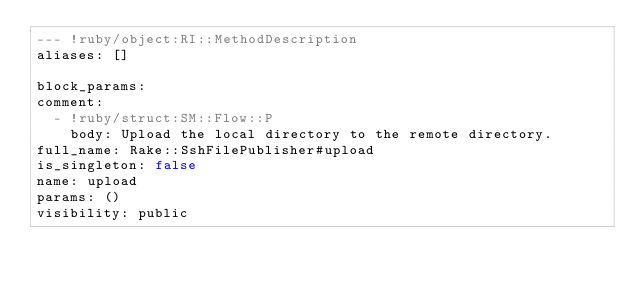Convert code to text. <code><loc_0><loc_0><loc_500><loc_500><_YAML_>--- !ruby/object:RI::MethodDescription 
aliases: []

block_params: 
comment: 
  - !ruby/struct:SM::Flow::P 
    body: Upload the local directory to the remote directory.
full_name: Rake::SshFilePublisher#upload
is_singleton: false
name: upload
params: ()
visibility: public
</code> 